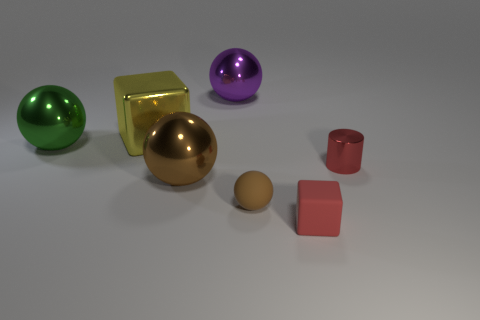There is another tiny object that is the same shape as the yellow metal thing; what is its color?
Ensure brevity in your answer.  Red. Do the big brown object and the tiny rubber object on the left side of the small red cube have the same shape?
Your answer should be compact. Yes. What size is the brown metal object that is the same shape as the big green metal thing?
Ensure brevity in your answer.  Large. What number of other things are there of the same color as the tiny rubber cube?
Provide a short and direct response. 1. Is there a red shiny thing of the same size as the yellow metallic cube?
Offer a very short reply. No. Is the small block the same color as the cylinder?
Offer a very short reply. Yes. The thing that is behind the cube on the left side of the red cube is what color?
Keep it short and to the point. Purple. How many metal spheres are behind the shiny cylinder and in front of the small red metallic thing?
Provide a succinct answer. 0. What number of green objects have the same shape as the large purple shiny thing?
Ensure brevity in your answer.  1. Do the tiny cube and the green ball have the same material?
Make the answer very short. No. 